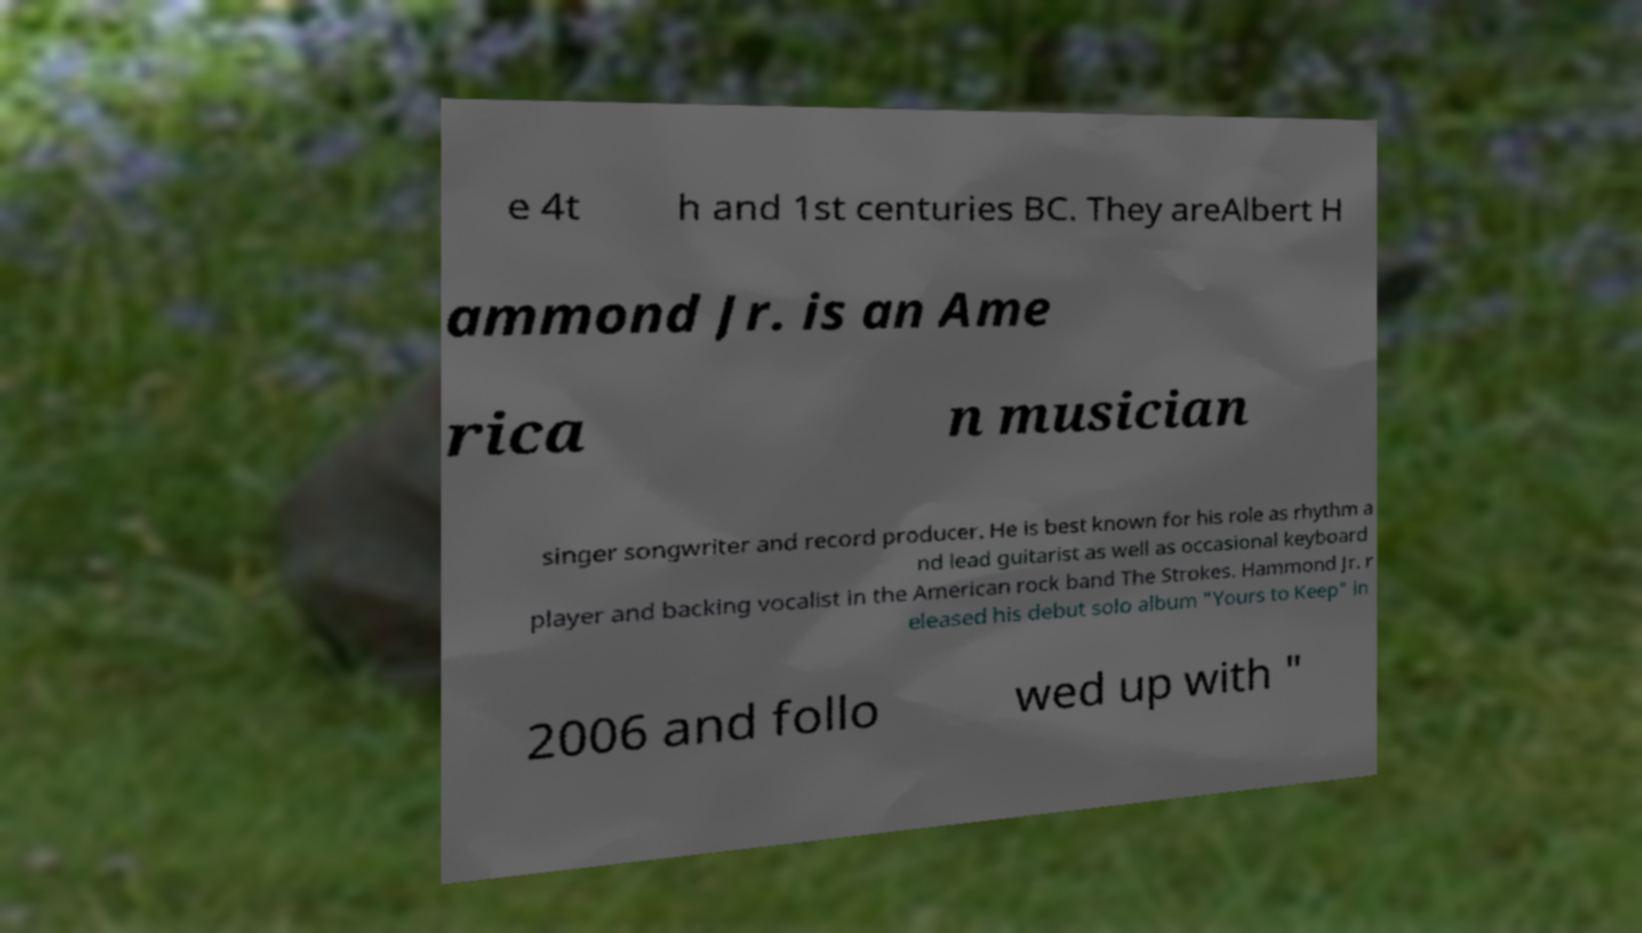Could you assist in decoding the text presented in this image and type it out clearly? e 4t h and 1st centuries BC. They areAlbert H ammond Jr. is an Ame rica n musician singer songwriter and record producer. He is best known for his role as rhythm a nd lead guitarist as well as occasional keyboard player and backing vocalist in the American rock band The Strokes. Hammond Jr. r eleased his debut solo album "Yours to Keep" in 2006 and follo wed up with " 